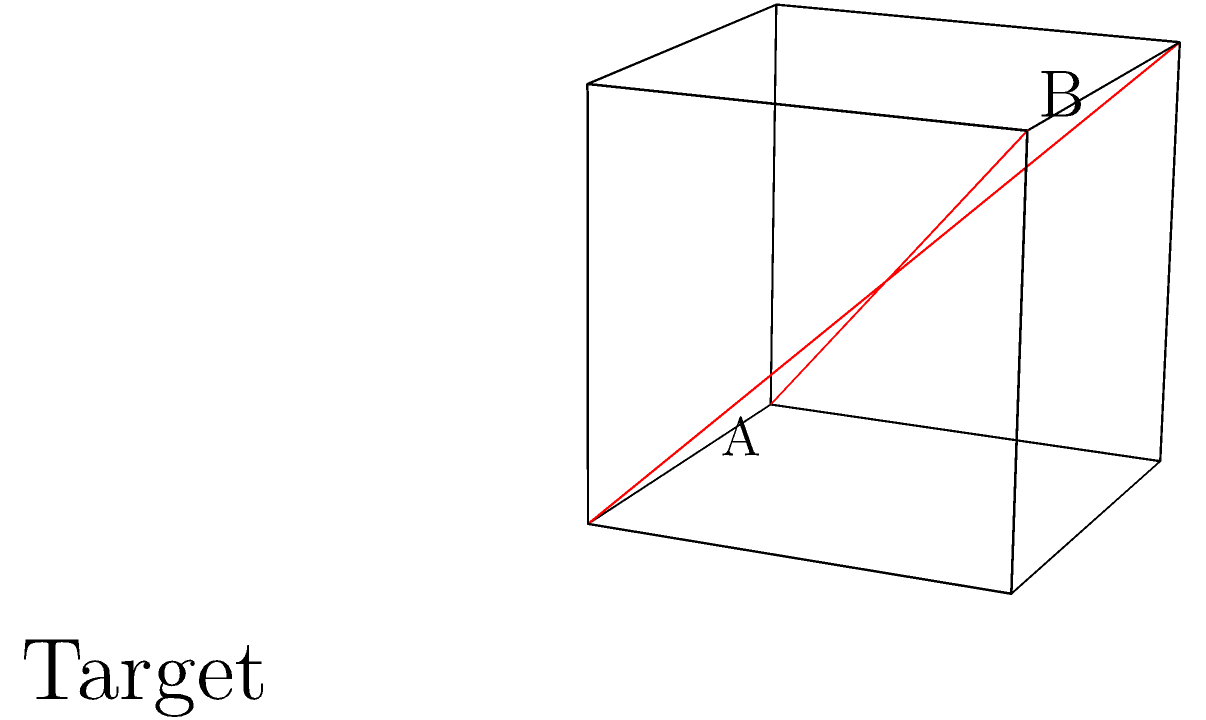A cube with a red diagonal from vertex A to the opposite corner B is shown. How many 90-degree rotations around its edges are required to transform the cube into the target configuration where the red diagonal connects the front-bottom-right vertex to the back-top-left vertex? To solve this problem, we need to mentally rotate the cube and count the number of 90-degree rotations required. Let's approach this step-by-step:

1. Observe the initial configuration:
   - The red diagonal goes from the front-bottom-left (A) to the back-top-right (B).

2. Observe the target configuration:
   - The red diagonal goes from the front-bottom-right to the back-top-left.

3. Analyze the required transformations:
   - We need to move the front-bottom-left vertex to the front-bottom-right position.
   - This can be achieved by rotating the cube 90 degrees around the vertical axis.

4. Perform the rotation:
   - After one 90-degree rotation around the vertical axis, the diagonal will go from the front-bottom-right to the back-top-left.

5. Check the result:
   - The cube now matches the target configuration.

6. Count the rotations:
   - We performed only one 90-degree rotation to achieve the target configuration.

Therefore, only one 90-degree rotation around the vertical edge of the cube is required to transform it into the target configuration.
Answer: 1 